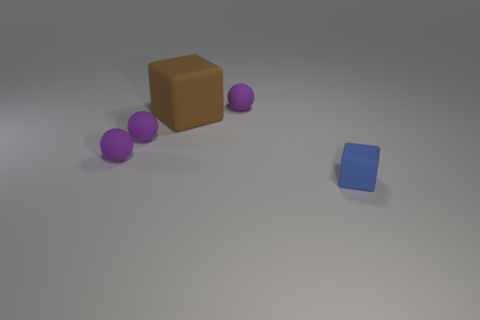What might be the purpose of this image, or what can it represent? This image could serve multiple purposes. It could be a simple study of geometric shapes and color, a visual exercise in composition and balance, or even an abstract representation of different entities in a system, with the brown and blue cubes symbolizing central hubs and the purple spheres acting as connecting nodes or data points. 